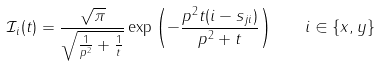<formula> <loc_0><loc_0><loc_500><loc_500>\mathcal { I } _ { i } ( t ) = \frac { \sqrt { \pi } } { \sqrt { \frac { 1 } { p ^ { 2 } } + \frac { 1 } { t } } } \exp { \left ( - \frac { p ^ { 2 } t ( i - s _ { j i } ) } { p ^ { 2 } + t } \right ) } \quad i \in \{ x , y \}</formula> 